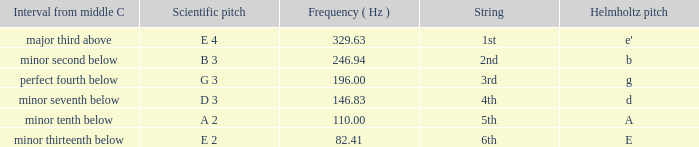What is the scientific pitch when the Helmholtz pitch is D? D 3. 